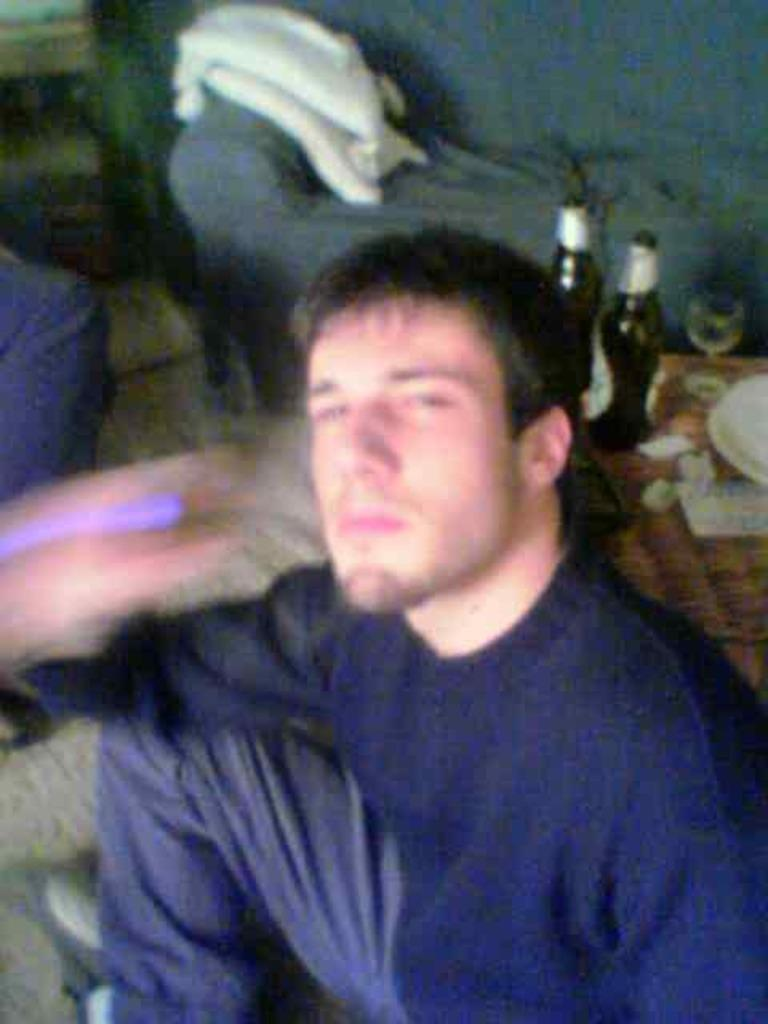What is the man in the image doing? The man is sitting in the image. What is the man wearing? The man is wearing clothes. How many bottles are visible in the image? There are two bottles in the image. What type of glass is present in the image? There is a wine glass in the image. Can you describe the background of the image? The background of the image is blurred. What type of basket is the man carrying as he walks in the image? There is no basket or indication of the man walking in the image. 